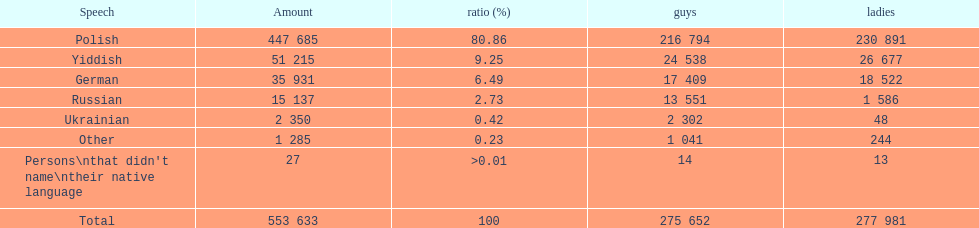Which is the least spoken language? Ukrainian. 